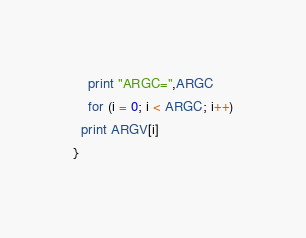Convert code to text. <code><loc_0><loc_0><loc_500><loc_500><_Awk_>    print "ARGC=",ARGC
    for (i = 0; i < ARGC; i++)
  print ARGV[i]
}
</code> 